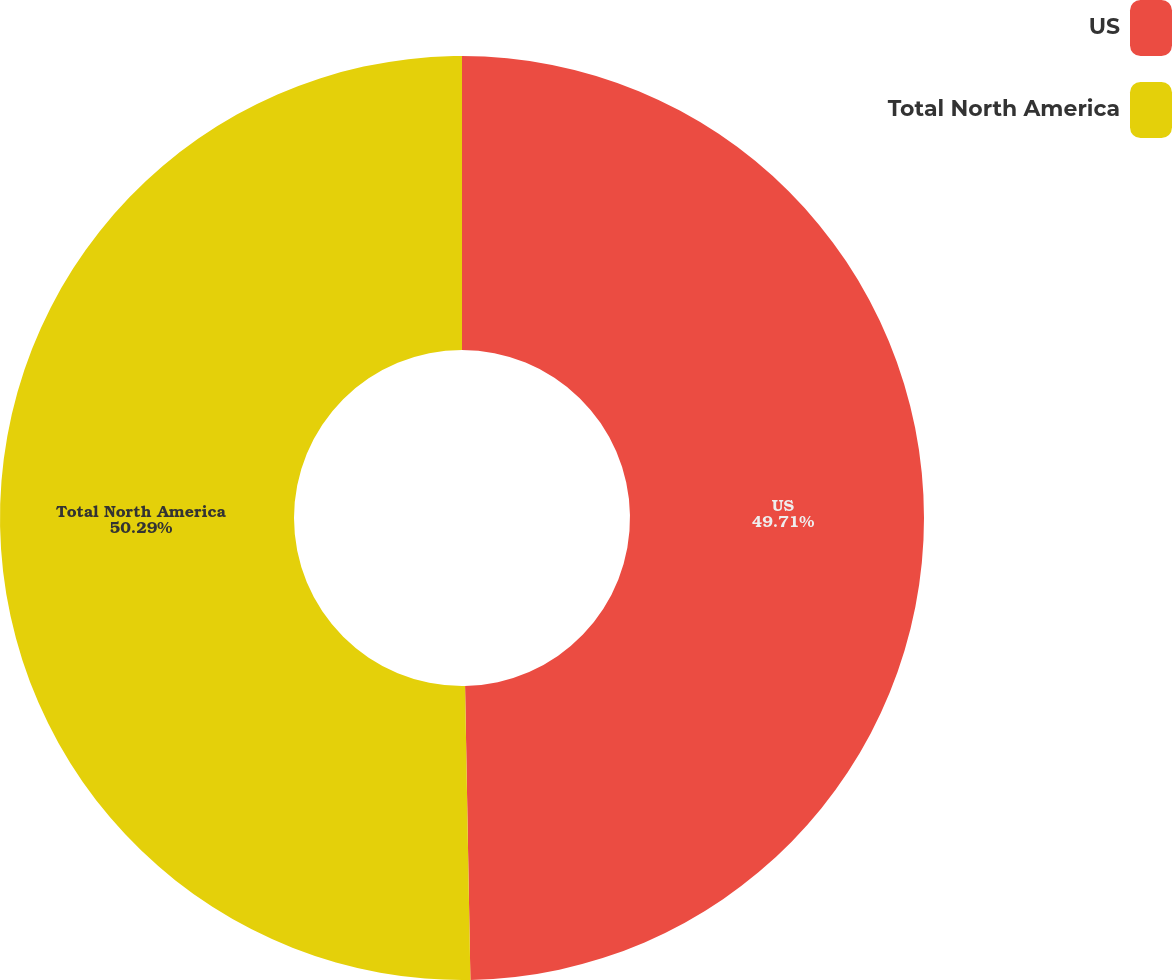Convert chart to OTSL. <chart><loc_0><loc_0><loc_500><loc_500><pie_chart><fcel>US<fcel>Total North America<nl><fcel>49.71%<fcel>50.29%<nl></chart> 